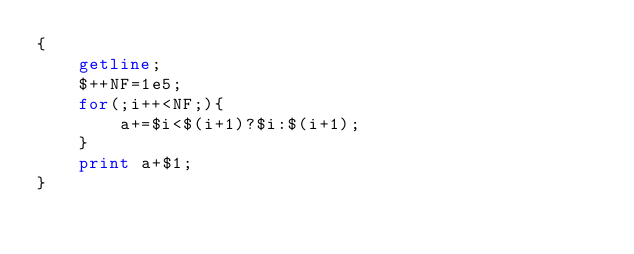Convert code to text. <code><loc_0><loc_0><loc_500><loc_500><_Awk_>{
    getline;
    $++NF=1e5;
    for(;i++<NF;){
        a+=$i<$(i+1)?$i:$(i+1);
    }
    print a+$1;
}</code> 